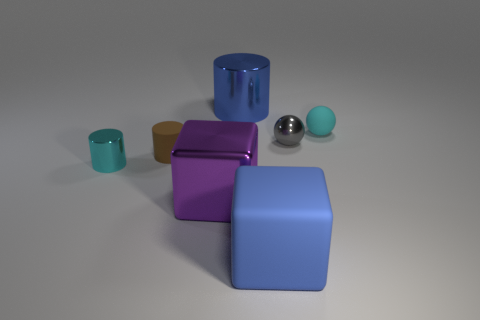Add 2 purple cubes. How many objects exist? 9 Subtract all cubes. How many objects are left? 5 Subtract 1 blue cubes. How many objects are left? 6 Subtract all small gray balls. Subtract all large cyan metal cylinders. How many objects are left? 6 Add 4 big blue cylinders. How many big blue cylinders are left? 5 Add 7 tiny green metal cylinders. How many tiny green metal cylinders exist? 7 